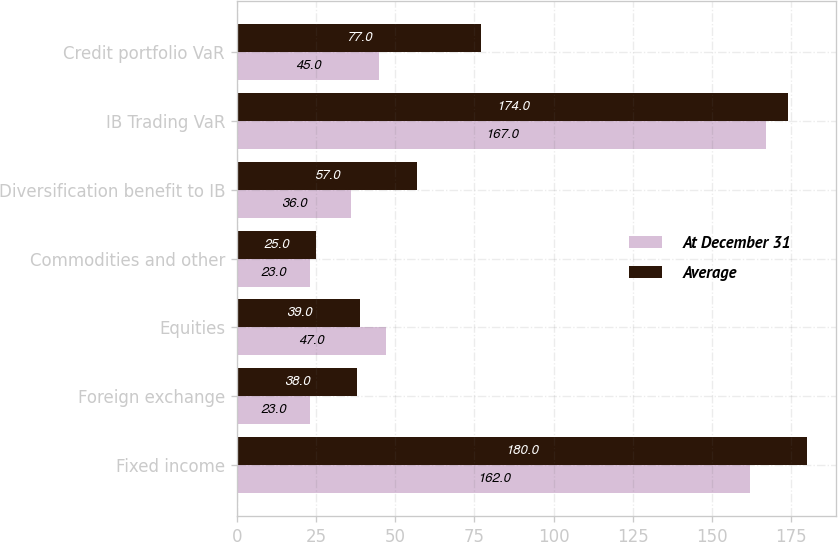Convert chart. <chart><loc_0><loc_0><loc_500><loc_500><stacked_bar_chart><ecel><fcel>Fixed income<fcel>Foreign exchange<fcel>Equities<fcel>Commodities and other<fcel>Diversification benefit to IB<fcel>IB Trading VaR<fcel>Credit portfolio VaR<nl><fcel>At December 31<fcel>162<fcel>23<fcel>47<fcel>23<fcel>36<fcel>167<fcel>45<nl><fcel>Average<fcel>180<fcel>38<fcel>39<fcel>25<fcel>57<fcel>174<fcel>77<nl></chart> 